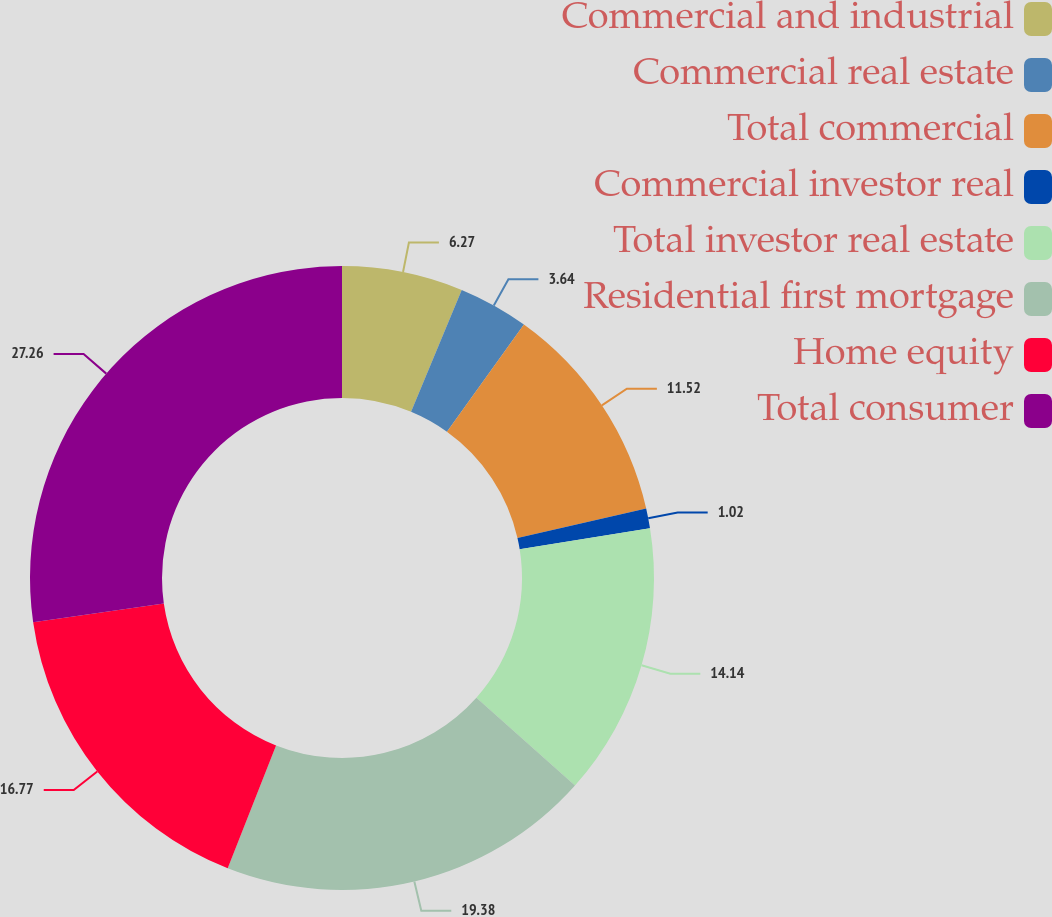Convert chart. <chart><loc_0><loc_0><loc_500><loc_500><pie_chart><fcel>Commercial and industrial<fcel>Commercial real estate<fcel>Total commercial<fcel>Commercial investor real<fcel>Total investor real estate<fcel>Residential first mortgage<fcel>Home equity<fcel>Total consumer<nl><fcel>6.27%<fcel>3.64%<fcel>11.52%<fcel>1.02%<fcel>14.14%<fcel>19.39%<fcel>16.77%<fcel>27.27%<nl></chart> 